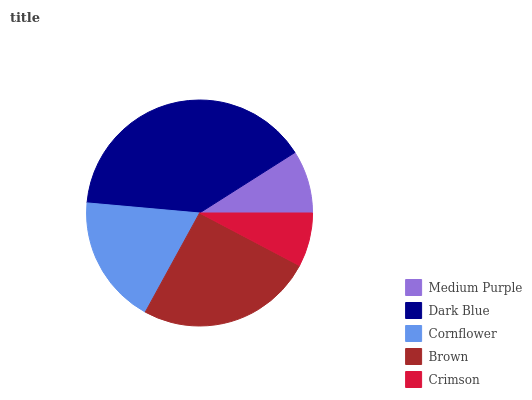Is Crimson the minimum?
Answer yes or no. Yes. Is Dark Blue the maximum?
Answer yes or no. Yes. Is Cornflower the minimum?
Answer yes or no. No. Is Cornflower the maximum?
Answer yes or no. No. Is Dark Blue greater than Cornflower?
Answer yes or no. Yes. Is Cornflower less than Dark Blue?
Answer yes or no. Yes. Is Cornflower greater than Dark Blue?
Answer yes or no. No. Is Dark Blue less than Cornflower?
Answer yes or no. No. Is Cornflower the high median?
Answer yes or no. Yes. Is Cornflower the low median?
Answer yes or no. Yes. Is Crimson the high median?
Answer yes or no. No. Is Crimson the low median?
Answer yes or no. No. 